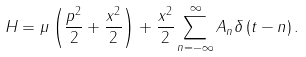Convert formula to latex. <formula><loc_0><loc_0><loc_500><loc_500>H = \mu \left ( \frac { p ^ { 2 } } { 2 } + \frac { x ^ { 2 } } { 2 } \right ) + \frac { x ^ { 2 } } { 2 } \sum _ { n = - \infty } ^ { \infty } A _ { n } \delta \left ( t - n \right ) .</formula> 